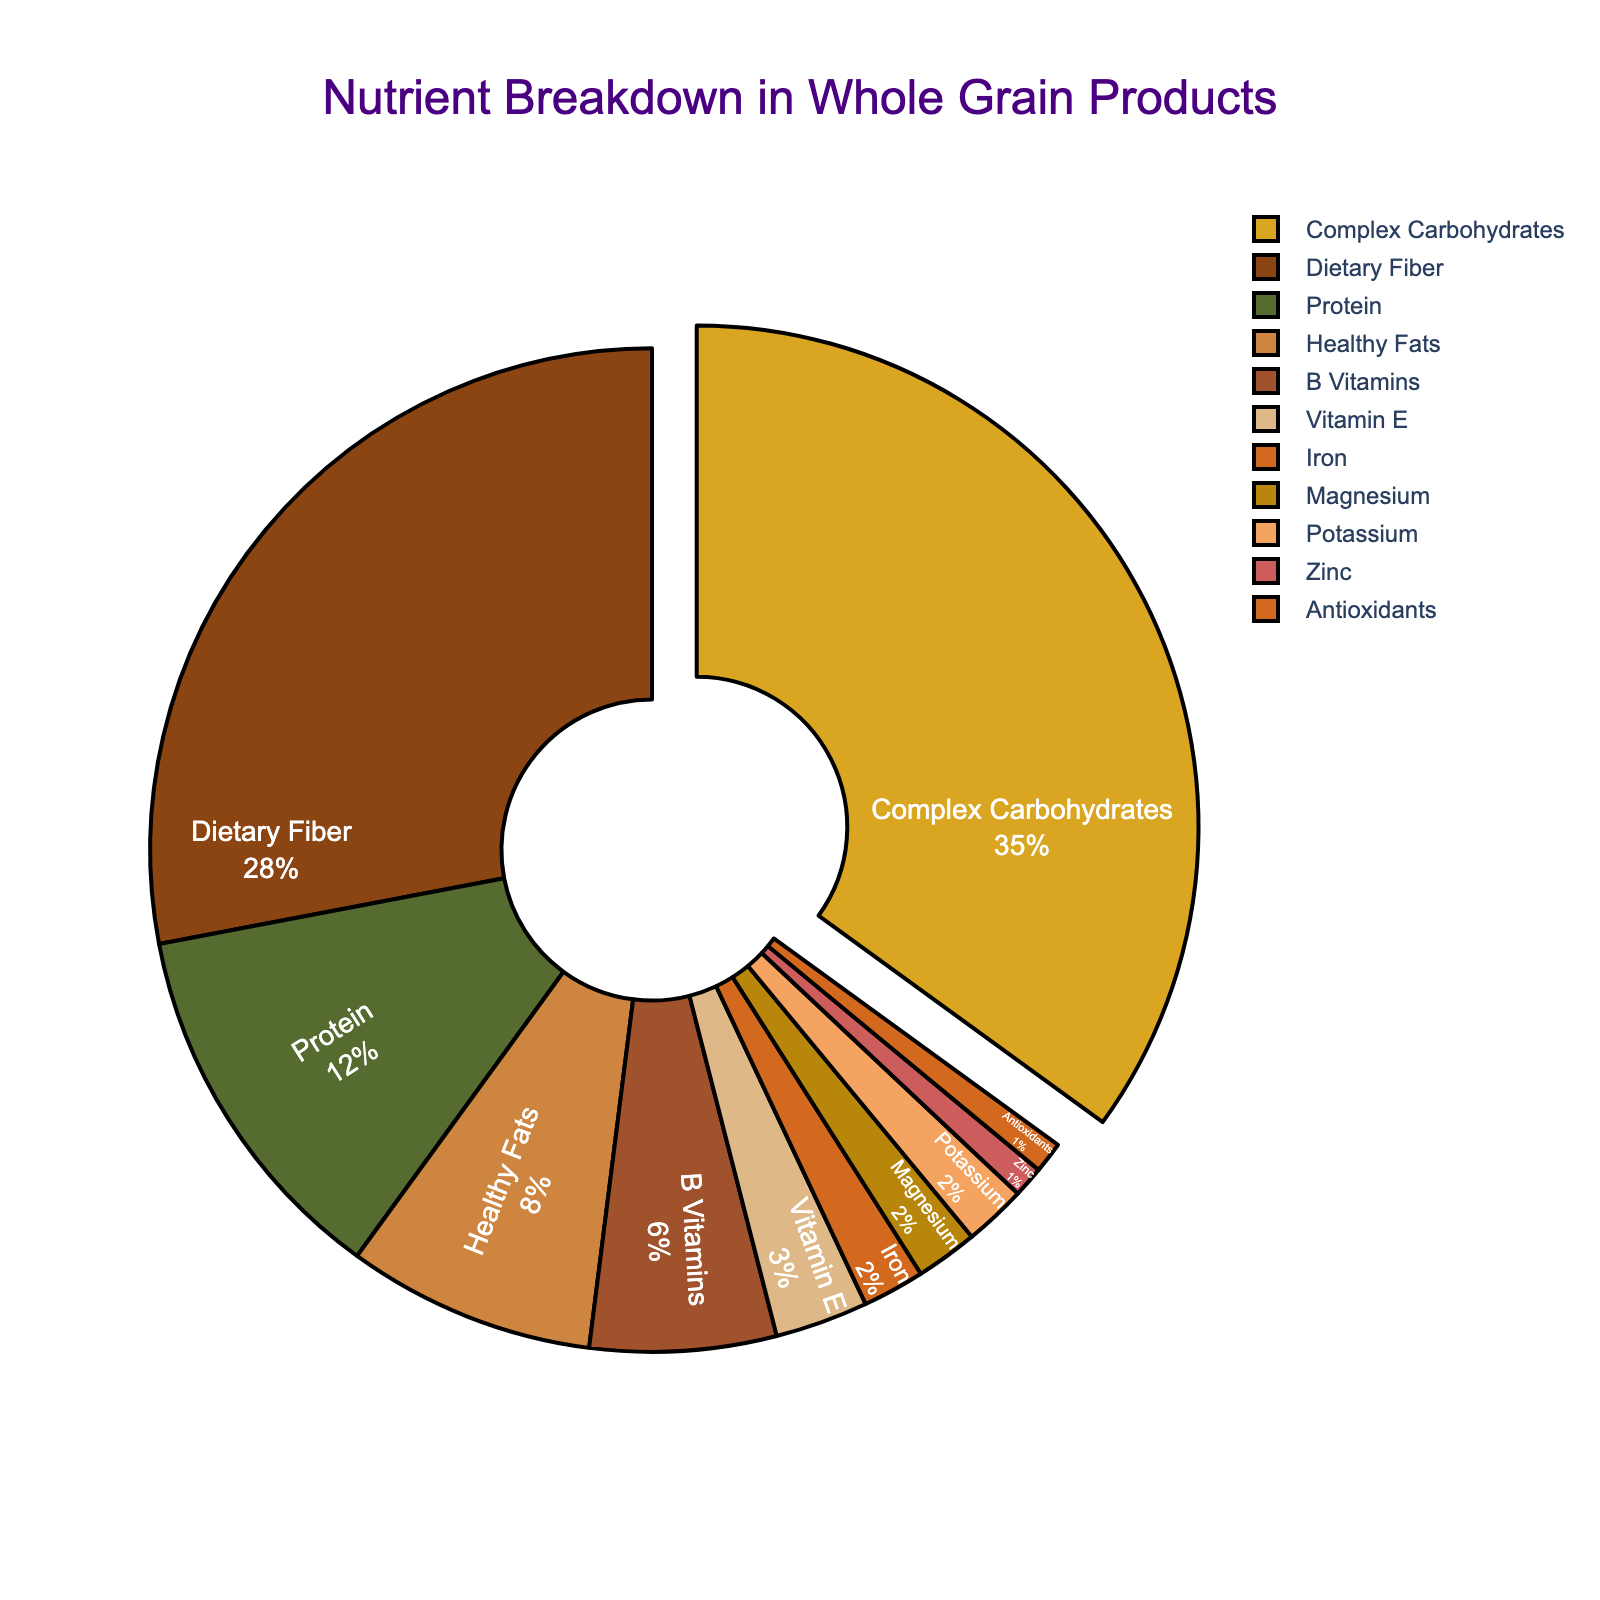What is the nutrient with the highest percentage? The figure shows the breakdown of nutrient content, and the section with the largest slice and the highest percentage mark is for Complex Carbohydrates.
Answer: Complex Carbohydrates How much greater is the percentage of Dietary Fiber compared to Protein? Dietery Fiber has a percentage of 28, while Protein has a percentage of 12. Subtract 12 from 28: 28 - 12 = 16.
Answer: 16 Which nutrients each have a percentage of 2%? The data for Iron, Magnesium, and Potassium each show a slice marked at 2%.
Answer: Iron, Magnesium, Potassium What is the total percentage of dietary fiber, protein, and healthy fats? Sum the percentages of Dietary Fiber, Protein, and Healthy Fats: 28 + 12 + 8 = 48.
Answer: 48 Which nutrient has a lower percentage: Magnesium or Vitamin E? Magnesium has a percentage of 2, while Vitamin E has 3. Comparing these values, Magnesium is lower.
Answer: Magnesium What proportion of the total nutrient content is made up of B Vitamins and Vitamin E? How does it compare to Protein? Sum the percentages of B Vitamins and Vitamin E: 6 + 3 = 9. Compare this sum with Protein, which is 12: 12 - 9 = 3, thus Protein accounts for 3% more.
Answer: 9, Protein is 3% more Which nutrients have a percentage of 1%? The figure shows that Zinc and Antioxidants each have a percentage slice marked at 1%.
Answer: Zinc, Antioxidants What is the combined percentage of Iron, Magnesium, and Zinc? Sum the percentages of Iron, Magnesium, and Zinc: 2 + 2 + 1 = 5.
Answer: 5 Which nutrient slice is colored red in the pie chart? The visual representation shows the red section is for Magnesium.
Answer: Magnesium How does the percentage of Healthy Fats compare to the combined percentage of Iron and Magnesium? Healthy Fats have a percentage of 8. Iron and Magnesium each have a percentage of 2, sum of which is 2 + 2 = 4. Therefore, Healthy Fats are twice as much: 8 - 4 = 4.
Answer: Healthy Fats are 4% more 